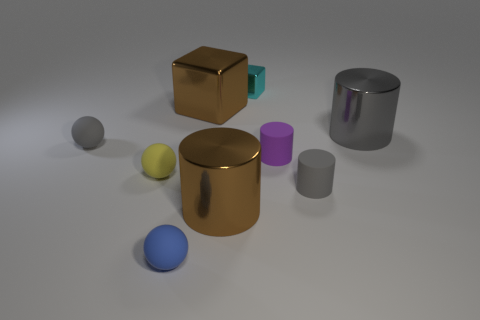Subtract all blue cylinders. Subtract all green balls. How many cylinders are left? 4 Add 1 balls. How many objects exist? 10 Subtract all spheres. How many objects are left? 6 Subtract all big cyan rubber cylinders. Subtract all tiny blocks. How many objects are left? 8 Add 2 blue matte objects. How many blue matte objects are left? 3 Add 6 gray shiny cylinders. How many gray shiny cylinders exist? 7 Subtract 1 yellow balls. How many objects are left? 8 